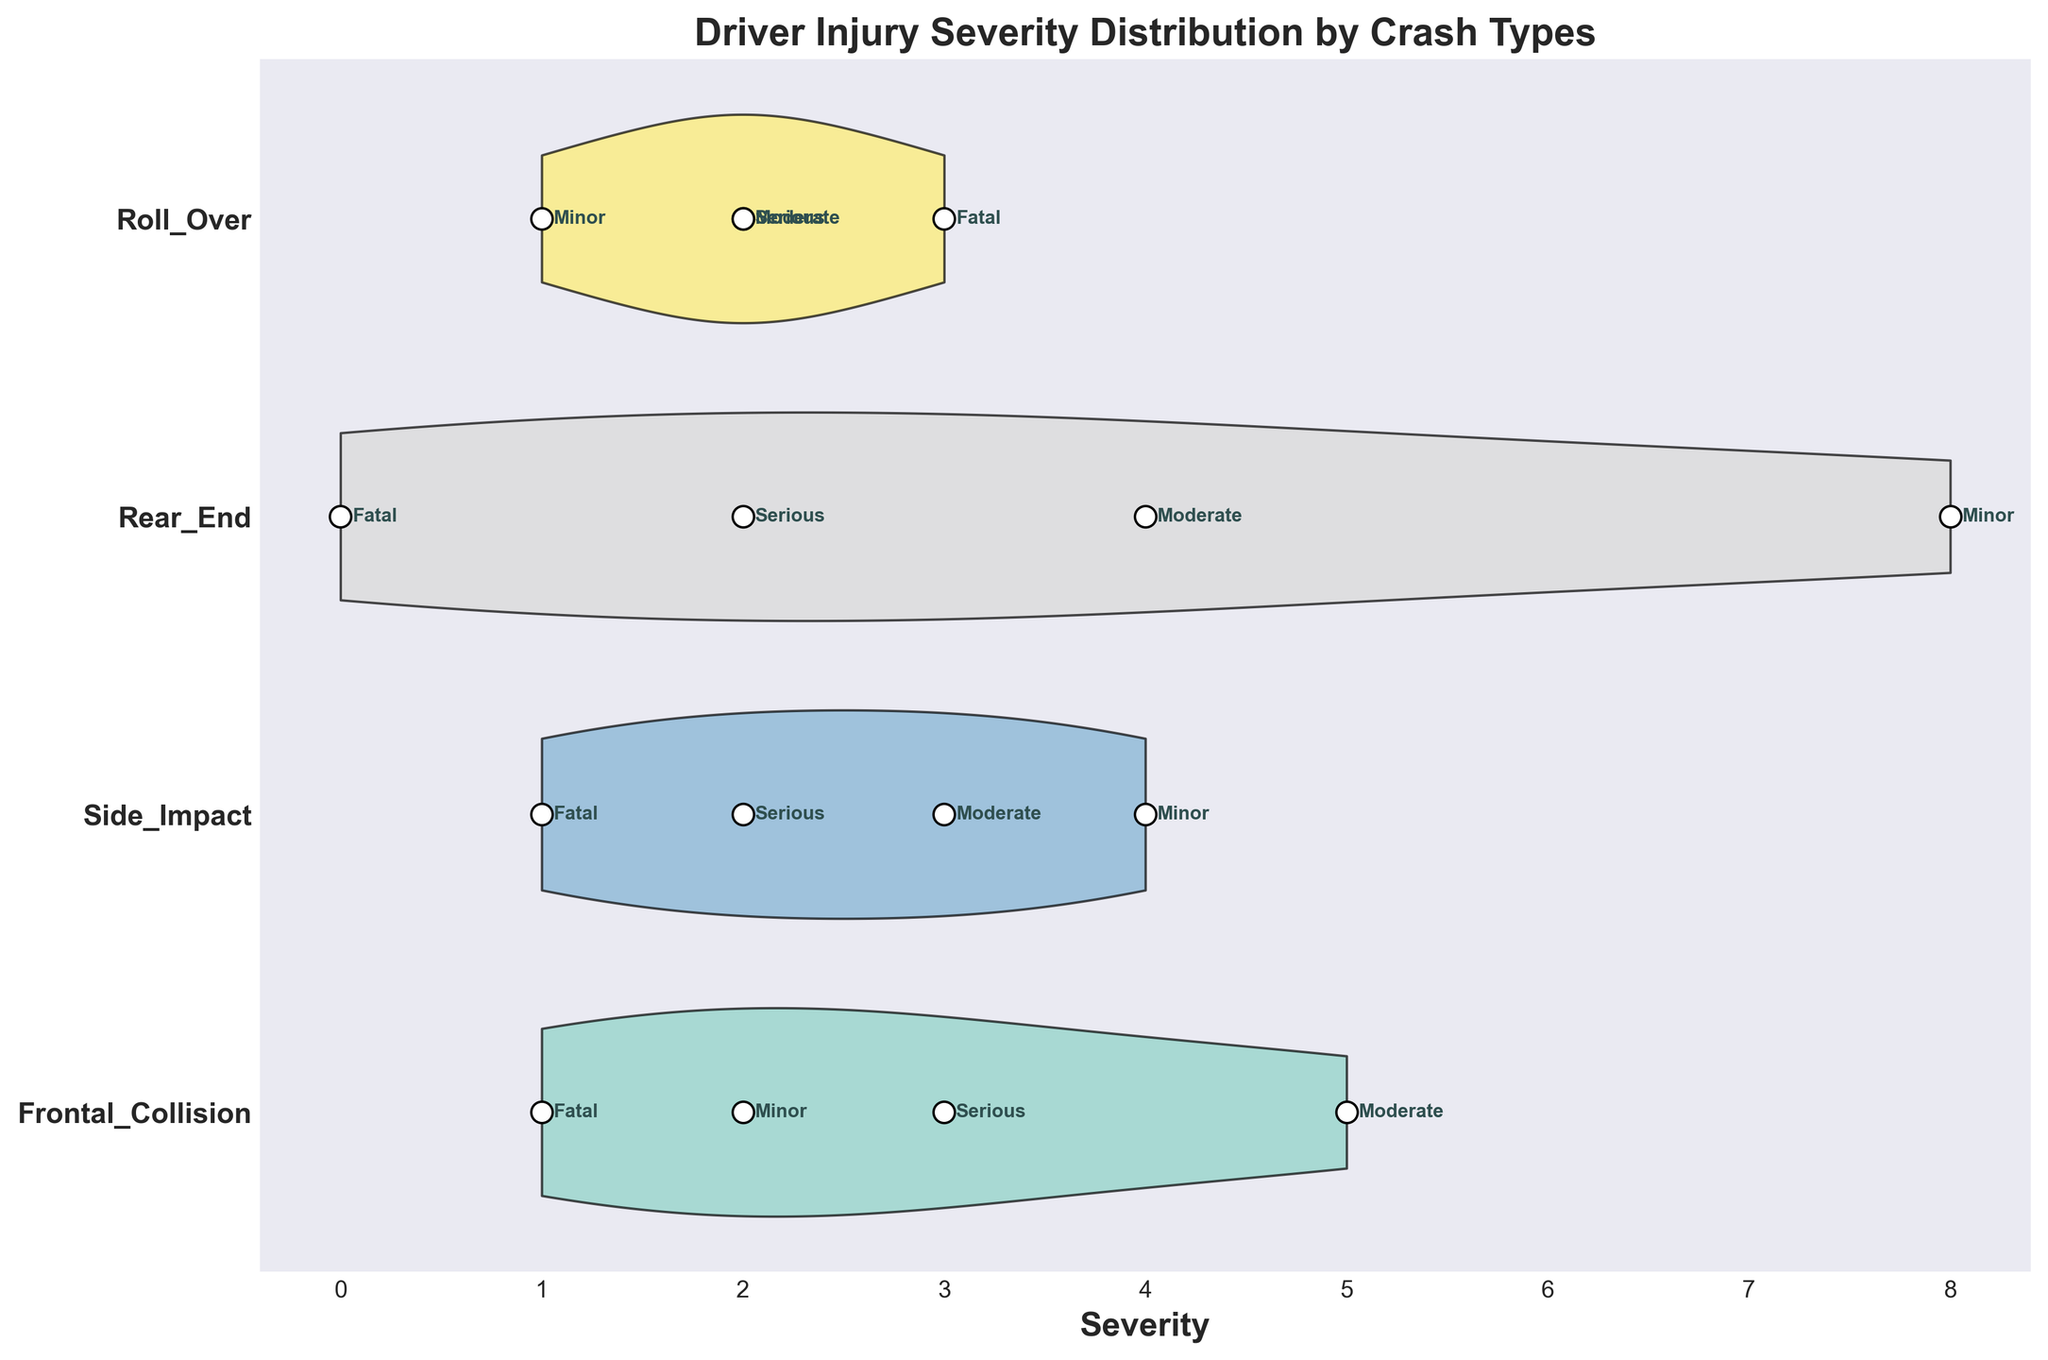What's the title of the chart? The title is prominently displayed at the top of the chart.
Answer: Driver Injury Severity Distribution by Crash Types How many different crash types are shown? Look at the y-axis labels to identify the unique crash types listed.
Answer: 4 Which crash type has the highest count of minor injuries? Count the data points labeled "Minor" for each crash type.
Answer: Rear_End Is there any crash type where the fatal injury count is higher than the serious injury count? Compare the fatal and serious injury counts for each crash type.
Answer: Roll_Over For Side Impact crashes, what are the severities associated with moderate injuries? Find the "Moderate" annotations under the Side Impact crash type and note the associated severity values.
Answer: 3 Which crash type shows the widest distribution of injury severities? Evaluate the spread of the violin plots for each crash type to determine which one is the widest.
Answer: Frontal_Collision Does any crash type have no fatal injuries? Check for a count of "Fatal" injuries under each crash type.
Answer: Rear_End Compare the counts of serious injuries between Frontal Collision and Roll Over crashes. Count the data points labeled "Serious" for both Frontal Collision and Roll Over crashes.
Answer: Frontal_Collision: 3, Roll_Over: 2 What is the most frequent injury severity for Rear End crashes? Identify the severity that appears most often within the Rear End crash type.
Answer: Minor Is the median severity of injuries higher for Side Impact or Roll Over crashes? Determine the median (middle value when sorted) of the severities for both crash types.
Answer: Roll_Over 